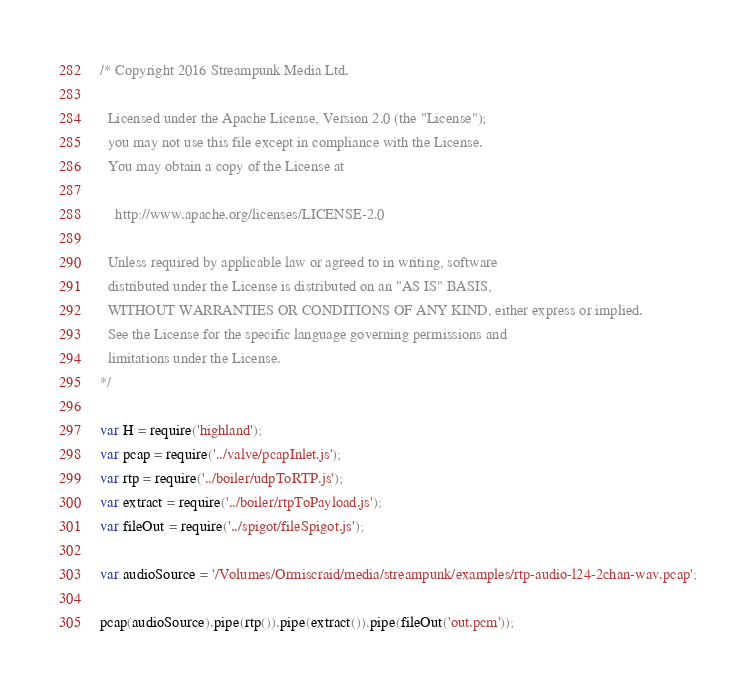Convert code to text. <code><loc_0><loc_0><loc_500><loc_500><_JavaScript_>/* Copyright 2016 Streampunk Media Ltd.

  Licensed under the Apache License, Version 2.0 (the "License");
  you may not use this file except in compliance with the License.
  You may obtain a copy of the License at

    http://www.apache.org/licenses/LICENSE-2.0

  Unless required by applicable law or agreed to in writing, software
  distributed under the License is distributed on an "AS IS" BASIS,
  WITHOUT WARRANTIES OR CONDITIONS OF ANY KIND, either express or implied.
  See the License for the specific language governing permissions and
  limitations under the License.
*/

var H = require('highland');
var pcap = require('../valve/pcapInlet.js');
var rtp = require('../boiler/udpToRTP.js');
var extract = require('../boiler/rtpToPayload.js');
var fileOut = require('../spigot/fileSpigot.js');

var audioSource = '/Volumes/Ormiscraid/media/streampunk/examples/rtp-audio-l24-2chan-wav.pcap';

pcap(audioSource).pipe(rtp()).pipe(extract()).pipe(fileOut('out.pcm'));
</code> 